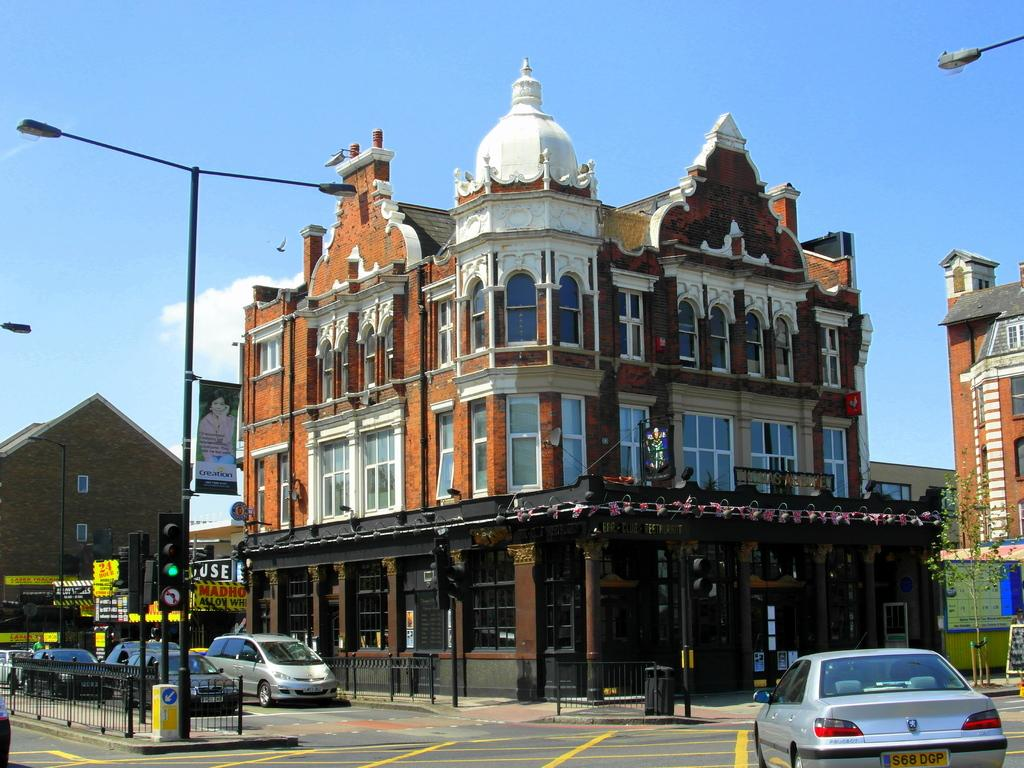What type of structures can be seen in the image? There are buildings in the image. What can be seen illuminating the area in the image? There are lights in the image. What are the vertical structures supporting the lights and signal lights? There are poles in the image. What type of traffic control devices are present in the image? There are signal lights in the image. What are the flat, rectangular objects with writing or images on them? There are boards in the image. What is the large, colorful piece of fabric with text or graphics in the image? There is a banner in the image. What is used for waste disposal in the image? There is a bin in the image. What are the long, horizontal bars used for in the image? There are railings in the image. What type of transportation is present in the image? There are vehicles in the image. What surface do the vehicles travel on in the image? There is a road in the image. What type of plant can be seen in the image? There is a tree in the image. What part of the natural environment is visible in the image? The sky is visible in the image. What is the relationship between the vehicles and the road in the image? Vehicles are on the road in the image. How many nuts are being cracked by the group in the image? There are no nuts or groups of people present in the image. What finger is pointing towards the sky in the image? There are no fingers pointing towards the sky in the image. 